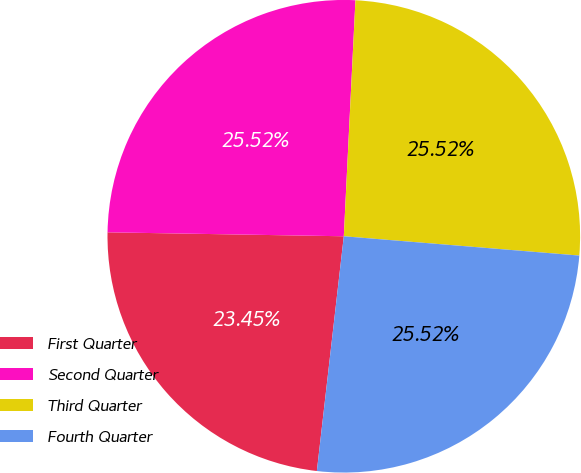Convert chart. <chart><loc_0><loc_0><loc_500><loc_500><pie_chart><fcel>First Quarter<fcel>Second Quarter<fcel>Third Quarter<fcel>Fourth Quarter<nl><fcel>23.45%<fcel>25.52%<fcel>25.52%<fcel>25.52%<nl></chart> 